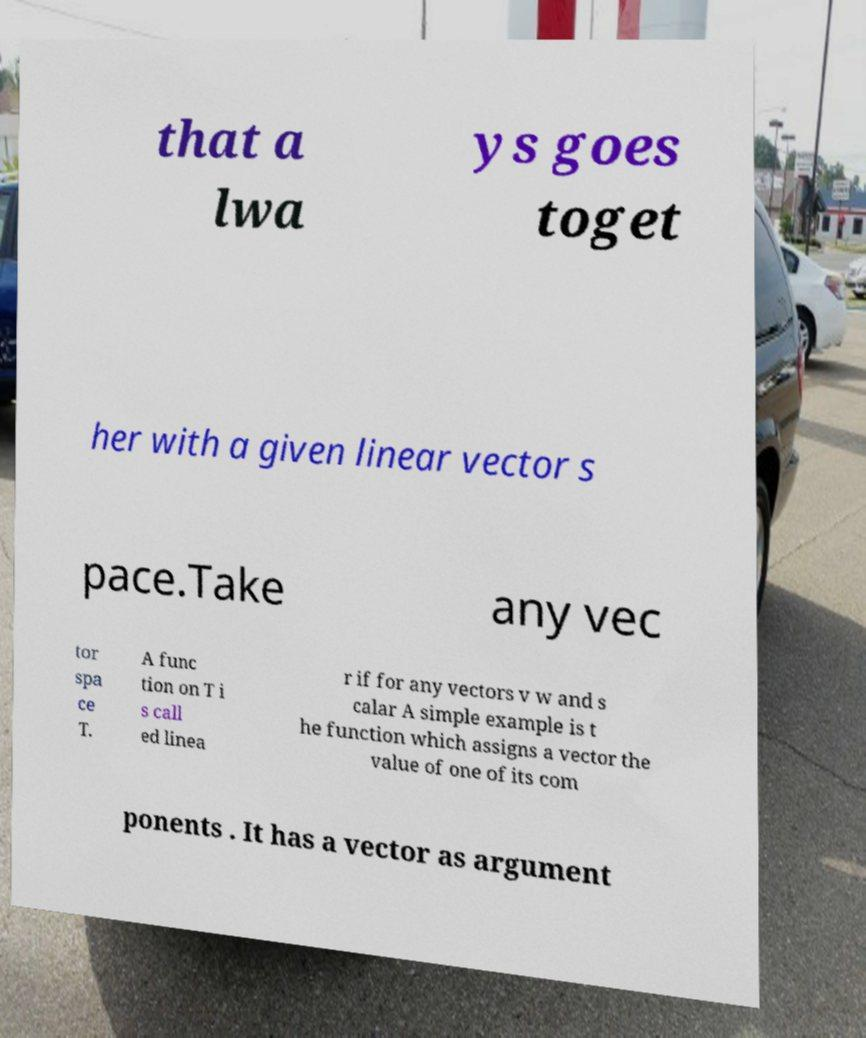Can you accurately transcribe the text from the provided image for me? that a lwa ys goes toget her with a given linear vector s pace.Take any vec tor spa ce T. A func tion on T i s call ed linea r if for any vectors v w and s calar A simple example is t he function which assigns a vector the value of one of its com ponents . It has a vector as argument 